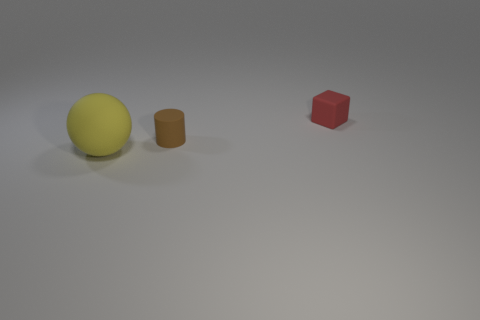Add 2 red matte balls. How many objects exist? 5 Subtract all cubes. How many objects are left? 2 Add 2 yellow rubber spheres. How many yellow rubber spheres are left? 3 Add 2 red things. How many red things exist? 3 Subtract 0 red spheres. How many objects are left? 3 Subtract all large cyan metal cylinders. Subtract all small brown things. How many objects are left? 2 